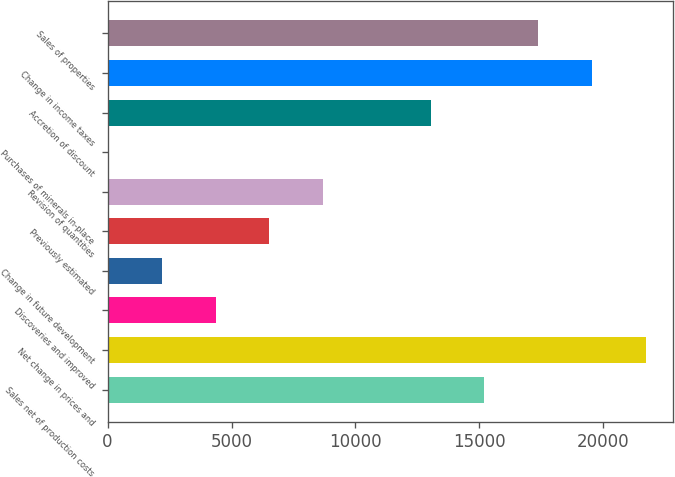Convert chart. <chart><loc_0><loc_0><loc_500><loc_500><bar_chart><fcel>Sales net of production costs<fcel>Net change in prices and<fcel>Discoveries and improved<fcel>Change in future development<fcel>Previously estimated<fcel>Revision of quantities<fcel>Purchases of minerals in-place<fcel>Accretion of discount<fcel>Change in income taxes<fcel>Sales of properties<nl><fcel>15203.6<fcel>21710<fcel>4359.6<fcel>2190.8<fcel>6528.4<fcel>8697.2<fcel>22<fcel>13034.8<fcel>19541.2<fcel>17372.4<nl></chart> 